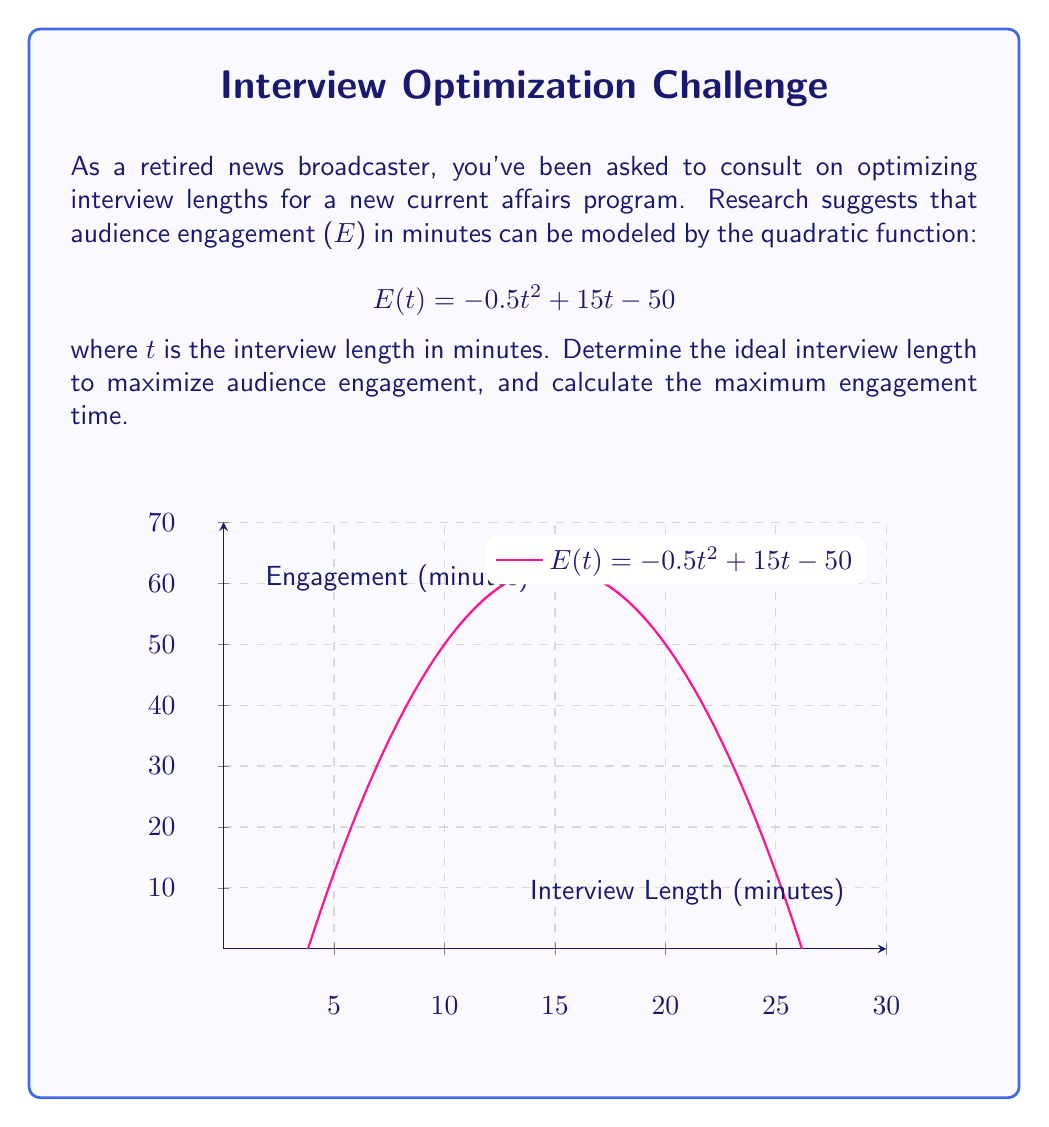Help me with this question. To find the ideal interview length that maximizes audience engagement, we need to find the vertex of the parabola represented by the quadratic function. The steps are as follows:

1) The quadratic function is in the form $$E(t) = at^2 + bt + c$$
   where $a = -0.5$, $b = 15$, and $c = -50$.

2) For a quadratic function, the t-coordinate of the vertex is given by $t = -\frac{b}{2a}$

3) Substituting the values:
   $$t = -\frac{15}{2(-0.5)} = -\frac{15}{-1} = 15$$

4) Therefore, the ideal interview length is 15 minutes.

5) To find the maximum engagement time, we substitute t = 15 into the original function:

   $$E(15) = -0.5(15)^2 + 15(15) - 50$$
   $$= -0.5(225) + 225 - 50$$
   $$= -112.5 + 225 - 50$$
   $$= 62.5$$

Thus, the maximum engagement time is 62.5 minutes.
Answer: Ideal interview length: 15 minutes; Maximum engagement: 62.5 minutes 